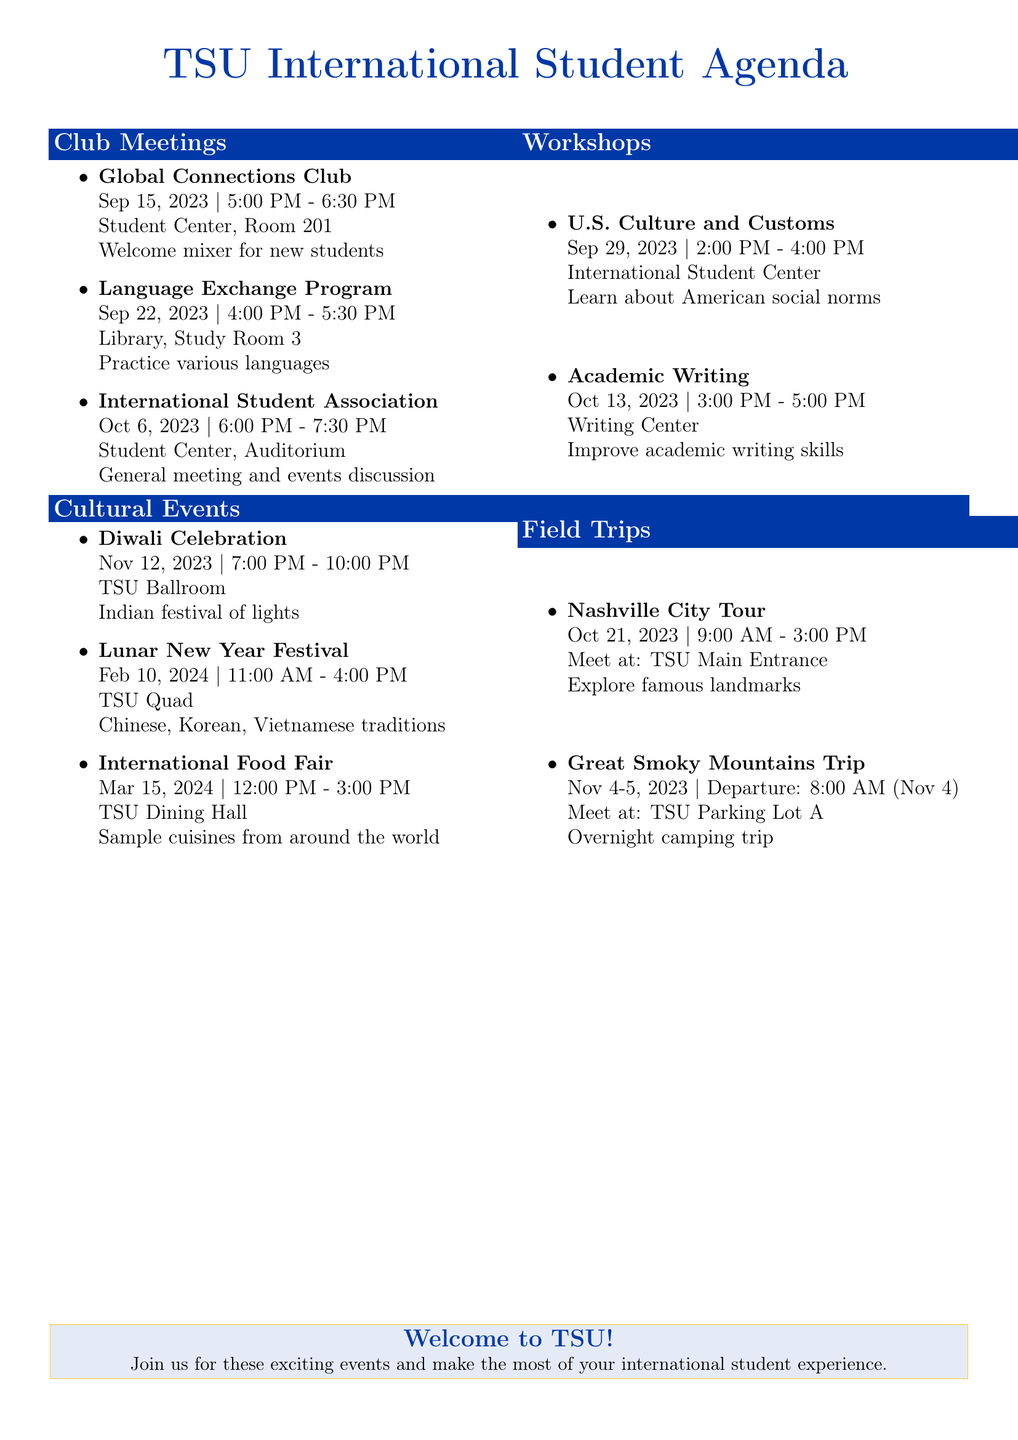what is the date of the Diwali Celebration? The date of the Diwali Celebration is specified in the cultural events section of the document.
Answer: November 12, 2023 where is the International Student Association meeting held? The location is mentioned in the club meetings section, detailing the place for the International Student Association meeting.
Answer: Student Center, Auditorium how many cultural events are listed in the document? The total number of cultural events is counted in the cultural events section of the document.
Answer: 3 what time does the Language Exchange Program start? The start time for the Language Exchange Program is provided in the club meetings section.
Answer: 4:00 PM which workshop focuses on academic skills? The workshops section gives details about various workshops, including one focused on academic skills.
Answer: Academic Writing for International Students when is the next field trip after October? This requires checking the field trips section to find one that occurs after October.
Answer: Great Smoky Mountains National Park Trip what is the theme of the Lunar New Year Festival? The theme is stated in the description of the event in the cultural events section.
Answer: Chinese, Korean, and Vietnamese traditions what is the location of the U.S. Culture and Customs workshop? The workshop's location is specifically mentioned in the workshops section of the document.
Answer: International Student Center how long does the Nashville City Tour last? The duration is inferred from the meeting times provided in the field trips section.
Answer: 6 hours 